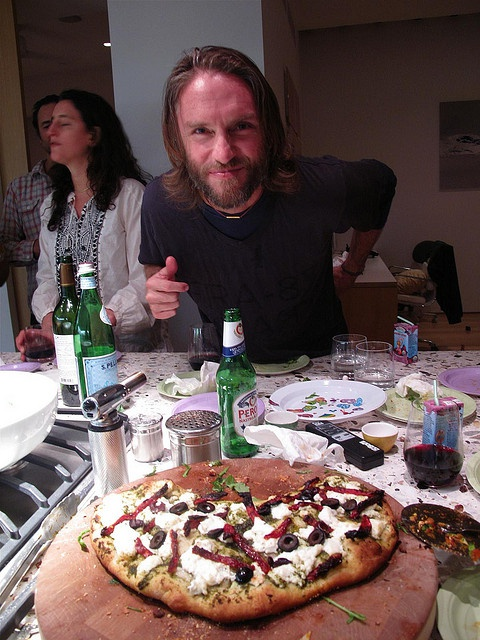Describe the objects in this image and their specific colors. I can see dining table in black, lightgray, brown, and darkgray tones, people in black, maroon, and brown tones, pizza in black, white, brown, and maroon tones, people in black, darkgray, gray, and maroon tones, and people in black, maroon, and gray tones in this image. 